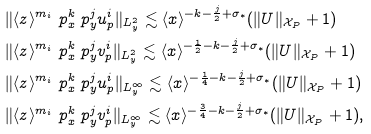<formula> <loc_0><loc_0><loc_500><loc_500>& \| \langle z \rangle ^ { m _ { i } } \ p _ { x } ^ { k } \ p _ { y } ^ { j } u ^ { i } _ { p } \| _ { L ^ { 2 } _ { y } } \lesssim \langle x \rangle ^ { - k - \frac { j } { 2 } + \sigma _ { \ast } } ( \| U \| _ { \mathcal { X } _ { P } } + 1 ) \\ & \| \langle z \rangle ^ { m _ { i } } \ p _ { x } ^ { k } \ p _ { y } ^ { j } v ^ { i } _ { p } \| _ { L ^ { 2 } _ { y } } \lesssim \langle x \rangle ^ { - \frac { 1 } { 2 } - k - \frac { j } { 2 } + \sigma _ { \ast } } ( \| U \| _ { \mathcal { X } _ { P } } + 1 ) \\ & \| \langle z \rangle ^ { m _ { i } } \ p _ { x } ^ { k } \ p _ { y } ^ { j } u _ { p } ^ { i } \| _ { L ^ { \infty } _ { y } } \lesssim \langle x \rangle ^ { - \frac { 1 } { 4 } - k - \frac { j } { 2 } + \sigma _ { \ast } } ( \| U \| _ { \mathcal { X } _ { P } } + 1 ) \\ & \| \langle z \rangle ^ { m _ { i } } \ p _ { x } ^ { k } \ p _ { y } ^ { j } v _ { p } ^ { i } \| _ { L ^ { \infty } _ { y } } \lesssim \langle x \rangle ^ { - \frac { 3 } { 4 } - k - \frac { j } { 2 } + \sigma _ { \ast } } ( \| U \| _ { \mathcal { X } _ { P } } + 1 ) ,</formula> 